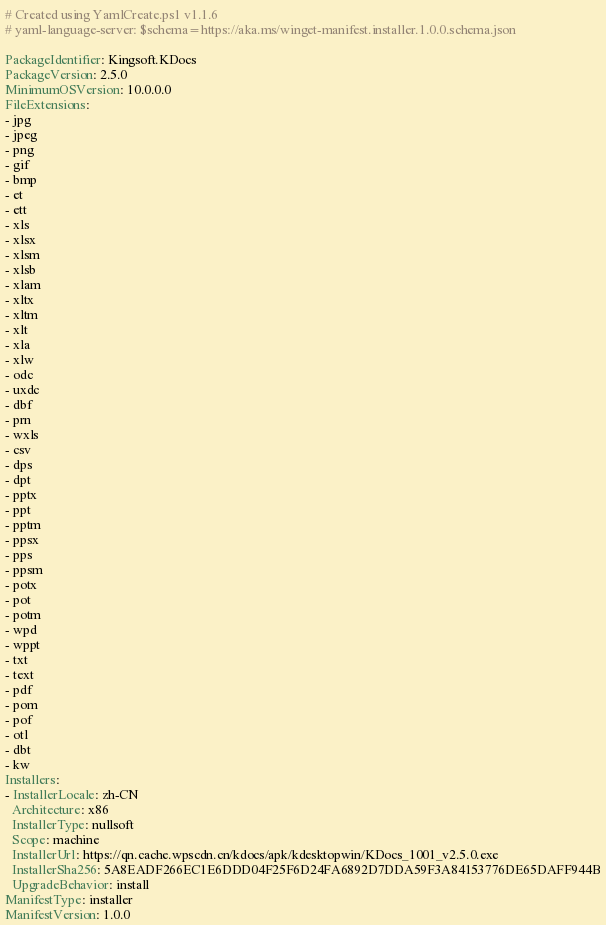<code> <loc_0><loc_0><loc_500><loc_500><_YAML_># Created using YamlCreate.ps1 v1.1.6
# yaml-language-server: $schema=https://aka.ms/winget-manifest.installer.1.0.0.schema.json

PackageIdentifier: Kingsoft.KDocs
PackageVersion: 2.5.0
MinimumOSVersion: 10.0.0.0
FileExtensions:
- jpg
- jpeg
- png
- gif
- bmp
- et
- ett
- xls
- xlsx
- xlsm
- xlsb
- xlam
- xltx
- xltm
- xlt
- xla
- xlw
- odc
- uxdc
- dbf
- prn
- wxls
- csv
- dps
- dpt
- pptx
- ppt
- pptm
- ppsx
- pps
- ppsm
- potx
- pot
- potm
- wpd
- wppt
- txt
- text
- pdf
- pom
- pof
- otl
- dbt
- kw
Installers:
- InstallerLocale: zh-CN
  Architecture: x86
  InstallerType: nullsoft
  Scope: machine
  InstallerUrl: https://qn.cache.wpscdn.cn/kdocs/apk/kdesktopwin/KDocs_1001_v2.5.0.exe
  InstallerSha256: 5A8EADF266EC1E6DDD04F25F6D24FA6892D7DDA59F3A84153776DE65DAFF944B
  UpgradeBehavior: install
ManifestType: installer
ManifestVersion: 1.0.0

</code> 